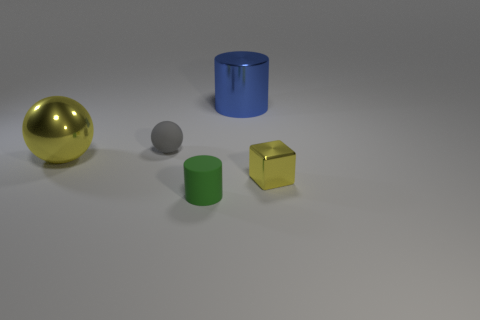Add 3 tiny matte balls. How many objects exist? 8 Subtract all balls. How many objects are left? 3 Subtract 1 cylinders. How many cylinders are left? 1 Subtract all gray spheres. Subtract all brown blocks. How many spheres are left? 1 Subtract all red blocks. How many gray cylinders are left? 0 Subtract all large purple metal balls. Subtract all small green matte things. How many objects are left? 4 Add 5 gray rubber spheres. How many gray rubber spheres are left? 6 Add 1 small cyan shiny blocks. How many small cyan shiny blocks exist? 1 Subtract 0 brown cylinders. How many objects are left? 5 